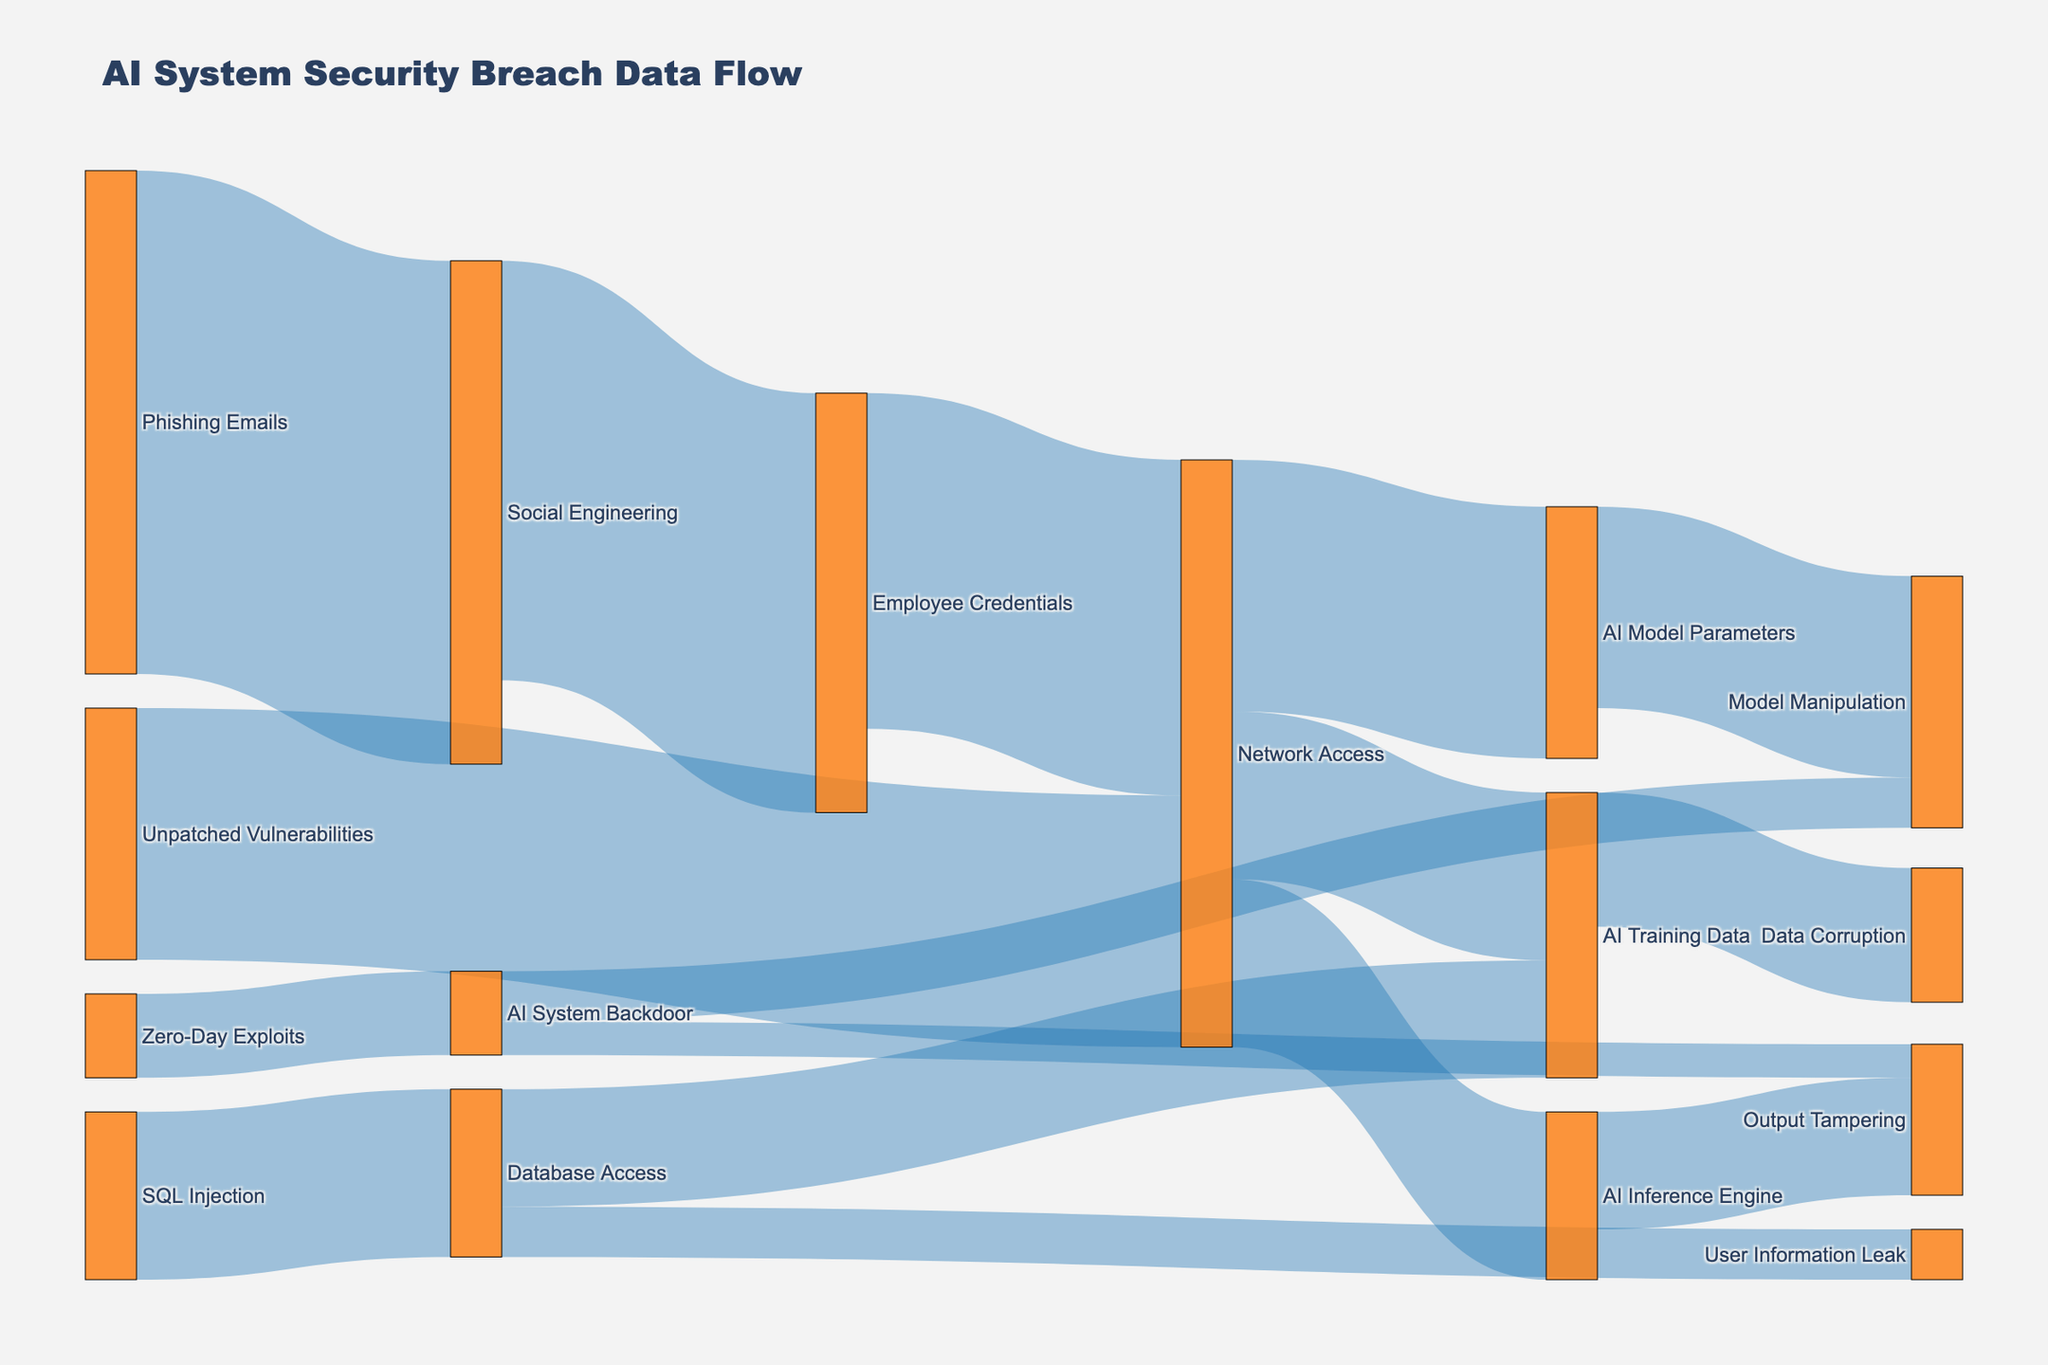What's the main entry point for AI system security breaches shown in the diagram? The main entry point can be identified by looking at which source node has the highest value flow to its target. Here, "Phishing Emails" leads to "Social Engineering" with a value of 30.
Answer: Phishing Emails Which component is most affected by Network Access? By tracing the flows from "Network Access," we can see three destination points: "AI Training Data" (10), "AI Model Parameters" (15), and "AI Inference Engine" (10). Among these, "AI Model Parameters" has the highest value at 15.
Answer: AI Model Parameters How many pathways lead to "Model Manipulation"? "Model Manipulation" receives flows from two sources: "AI Model Parameters" (12) and "AI System Backdoor" (3). Therefore, there are two pathways.
Answer: 2 What is the total value flowing into "Network Access"? To find the total value flowing into "Network Access," sum the incoming flows from "Employee Credentials" (20) and "Unpatched Vulnerabilities" (15). The total is 20 + 15 = 35.
Answer: 35 What percentage of the flow from "Network Access" goes to "AI Training Data"? From "Network Access," three flows go out: "AI Training Data" (10), "AI Model Parameters" (15), and "AI Inference Engine" (10), totaling 35. The percentage for "AI Training Data" is (10 / 35) * 100 ≈ 28.6%.
Answer: ≈ 28.6% Is "SQL Injection" or "Zero-Day Exploits" a bigger threat to "AI Training Data"? By examining the flow values, "SQL Injection" leads to "AI Training Data" with a value of 7, while "Zero-Day Exploits" does not directly lead to it. Hence, "SQL Injection" is a bigger threat.
Answer: SQL Injection Which type of exploit has a direct path to output tampering? Two paths lead directly to "Output Tampering": "AI Inference Engine" (7) and "AI System Backdoor" (2). So, "AI System Backdoor" and "Network Access" via the "AI Inference Engine" lead to output tampering.
Answer: AI System Backdoor, Network Access How much flow does "Employee Credentials" govern through "Social Engineering"? "Social Engineering" leads to "Employee Credentials" with a value of 25. Therefore, "Employee Credentials" governs a flow of 25 from "Social Engineering".
Answer: 25 What is the most critical flow path that leads to "User Information Leak"? The flow path to "User Information Leak" is "SQL Injection" leading to "Database Access" (10), and then to "User Information Leak" (3). This indicates it is an indirect but critical path.
Answer: SQL Injection -> Database Access -> User Information Leak Count the number of nodes in the diagram. By examining the unique elements in the nodes list, there are 13 unique nodes in the diagram.
Answer: 13 